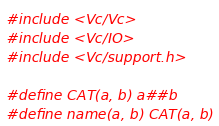<code> <loc_0><loc_0><loc_500><loc_500><_C++_>#include <Vc/Vc>
#include <Vc/IO>
#include <Vc/support.h>

#define CAT(a, b) a##b
#define name(a, b) CAT(a, b)
</code> 